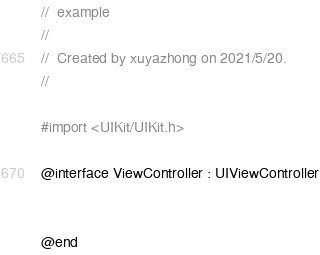<code> <loc_0><loc_0><loc_500><loc_500><_C_>//  example
//
//  Created by xuyazhong on 2021/5/20.
//

#import <UIKit/UIKit.h>

@interface ViewController : UIViewController


@end

</code> 